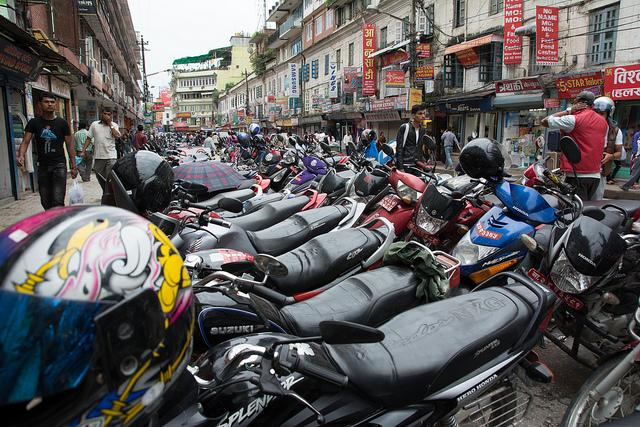The motorbikes on this bustling city street are present in which country? Please explain your reasoning. india. That country is known to have many of those vehicles. there are many very dark-skinned men who don't have that east-asian look, thus the selected country. 